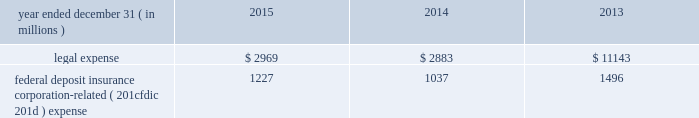Jpmorgan chase & co./2015 annual report 233 note 11 2013 noninterest expense for details on noninterest expense , see consolidated statements of income on page 176 .
Included within other expense is the following : year ended december 31 , ( in millions ) 2015 2014 2013 .
Federal deposit insurance corporation-related ( 201cfdic 201d ) expense 1227 1037 1496 note 12 2013 securities securities are classified as trading , afs or held-to-maturity ( 201chtm 201d ) .
Securities classified as trading assets are discussed in note 3 .
Predominantly all of the firm 2019s afs and htm investment securities ( the 201cinvestment securities portfolio 201d ) are held by treasury and cio in connection with its asset-liability management objectives .
At december 31 , 2015 , the investment securities portfolio consisted of debt securities with an average credit rating of aa+ ( based upon external ratings where available , and where not available , based primarily upon internal ratings which correspond to ratings as defined by s&p and moody 2019s ) .
Afs securities are carried at fair value on the consolidated balance sheets .
Unrealized gains and losses , after any applicable hedge accounting adjustments , are reported as net increases or decreases to accumulated other comprehensive income/ ( loss ) .
The specific identification method is used to determine realized gains and losses on afs securities , which are included in securities gains/ ( losses ) on the consolidated statements of income .
Htm debt securities , which management has the intent and ability to hold until maturity , are carried at amortized cost on the consolidated balance sheets .
For both afs and htm debt securities , purchase discounts or premiums are generally amortized into interest income over the contractual life of the security .
During 2014 , the firm transferred u.s .
Government agency mortgage-backed securities and obligations of u.s .
States and municipalities with a fair value of $ 19.3 billion from afs to htm .
These securities were transferred at fair value , and the transfer was a non-cash transaction .
Aoci included net pretax unrealized losses of $ 9 million on the securities at the date of transfer .
The transfer reflected the firm 2019s intent to hold the securities to maturity in order to reduce the impact of price volatility on aoci and certain capital measures under basel iii. .
What was the percent of the other expenses federal deposit insurance corporation-related ( 201cfdic 201d ) expense as a percent of the legal expense? 
Computations: (1227 / 2969)
Answer: 0.41327. 